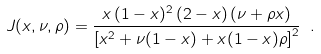<formula> <loc_0><loc_0><loc_500><loc_500>J ( x , \nu , \rho ) = \frac { x \, ( 1 - x ) ^ { 2 } \, ( 2 - x ) \, ( \nu + \rho x ) } { \left [ x ^ { 2 } + \nu ( 1 - x ) + x ( 1 - x ) \rho \right ] ^ { 2 } } \ .</formula> 